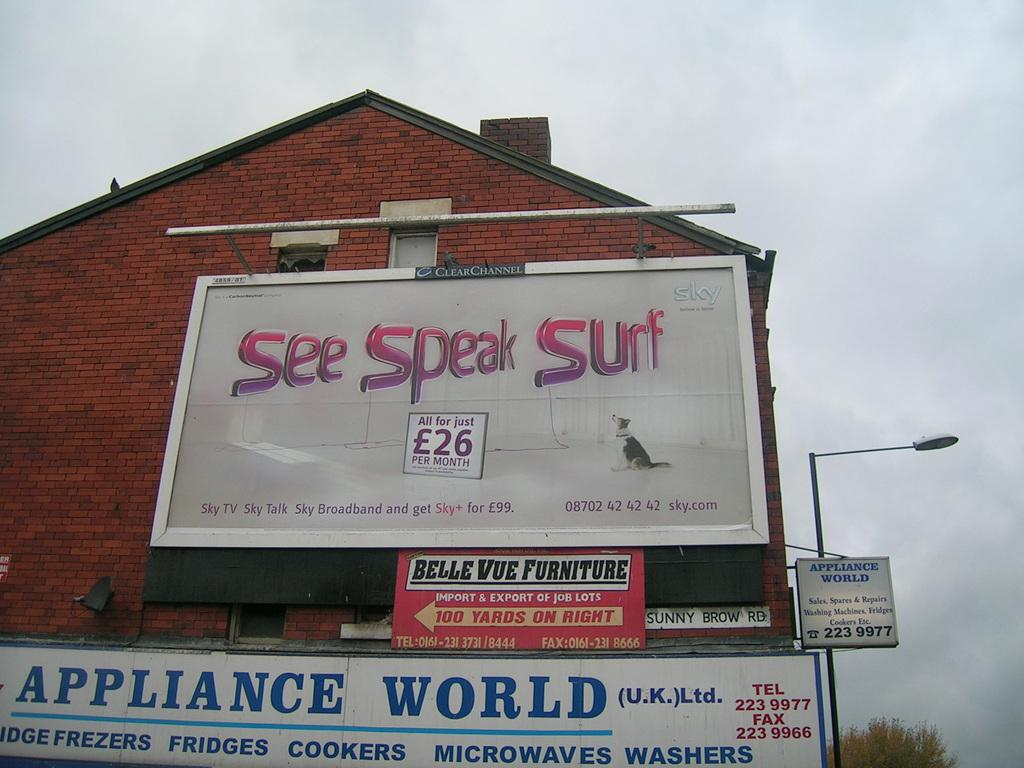Provide a one-sentence caption for the provided image. A house with billboards on the side reading Speak Surf and Appliance World. 